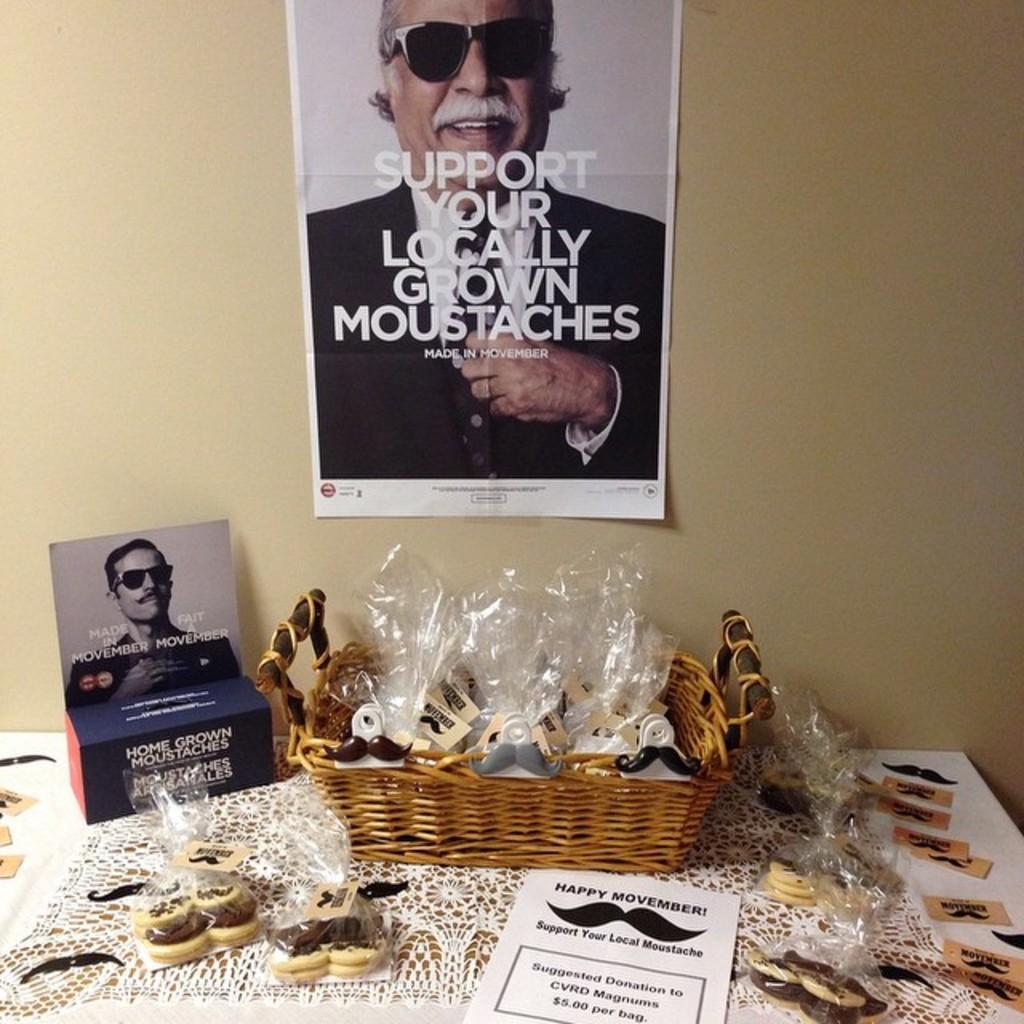Can you describe this image briefly? In the image we can see there are moustache shaped biscuits kept on the table and there are other moustache shaped items kept in the basket. There is a poster on the wall on which there is a picture of a man on it. 